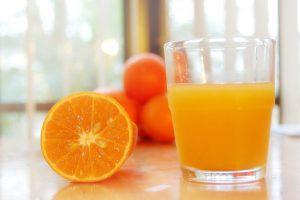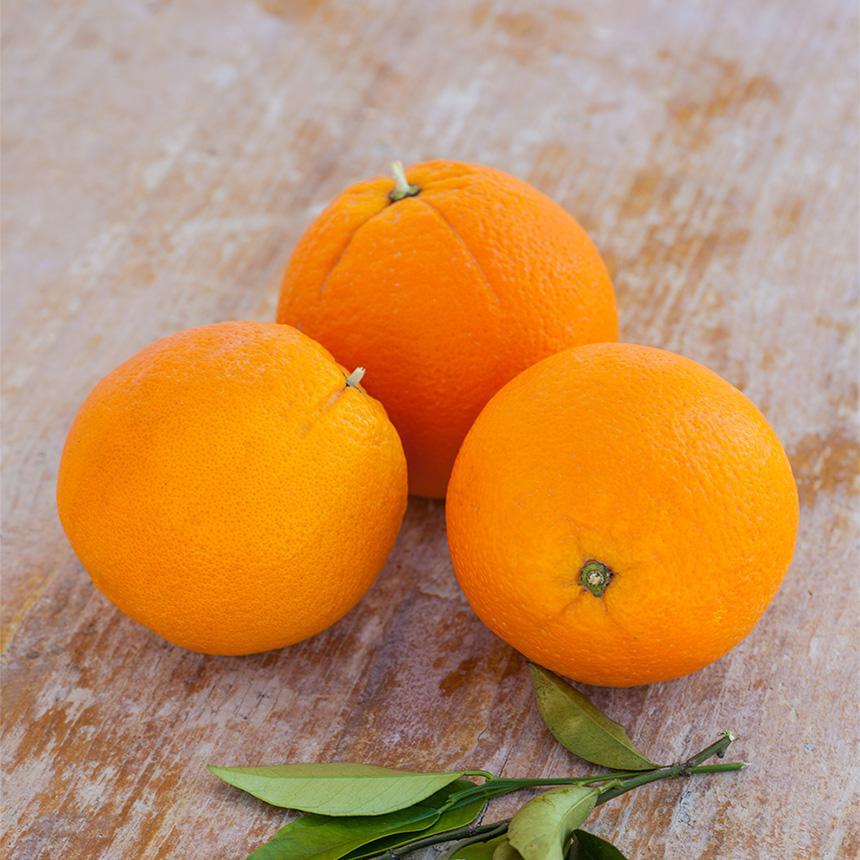The first image is the image on the left, the second image is the image on the right. Given the left and right images, does the statement "There are four unpeeled oranges in the pair of images." hold true? Answer yes or no. No. The first image is the image on the left, the second image is the image on the right. Analyze the images presented: Is the assertion "One of the images has two whole oranges with no partially cut oranges." valid? Answer yes or no. No. 